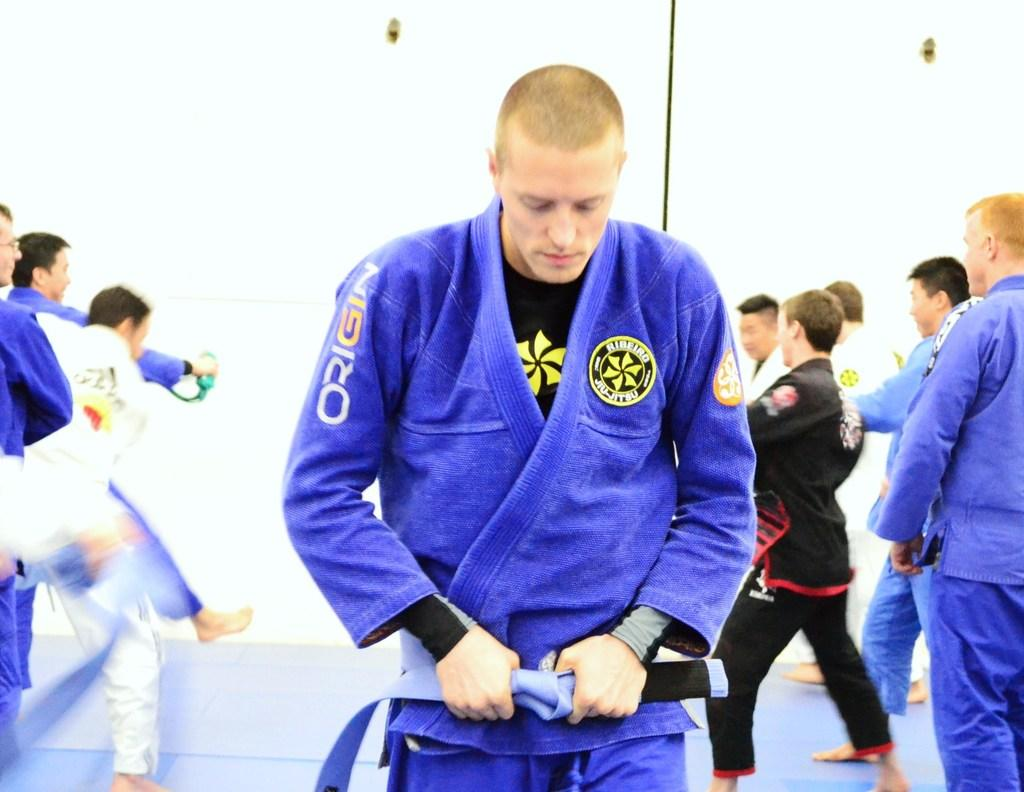<image>
Provide a brief description of the given image. A man in a martial arts suit which has the word Origin on the arm. 